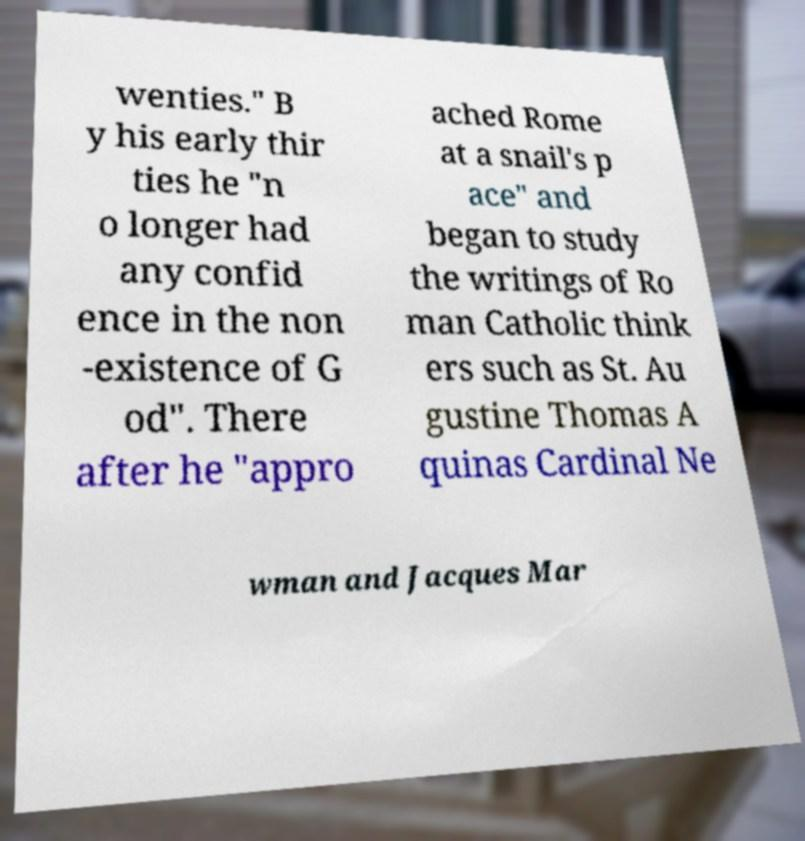Could you extract and type out the text from this image? wenties." B y his early thir ties he "n o longer had any confid ence in the non -existence of G od". There after he "appro ached Rome at a snail's p ace" and began to study the writings of Ro man Catholic think ers such as St. Au gustine Thomas A quinas Cardinal Ne wman and Jacques Mar 